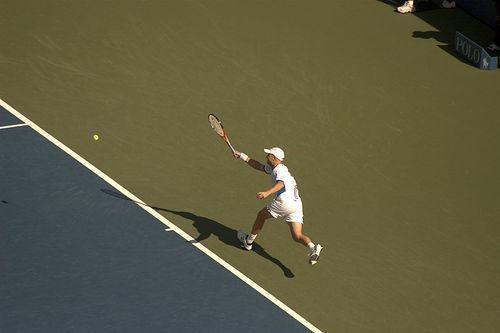How many of the airplanes have entrails?
Give a very brief answer. 0. 